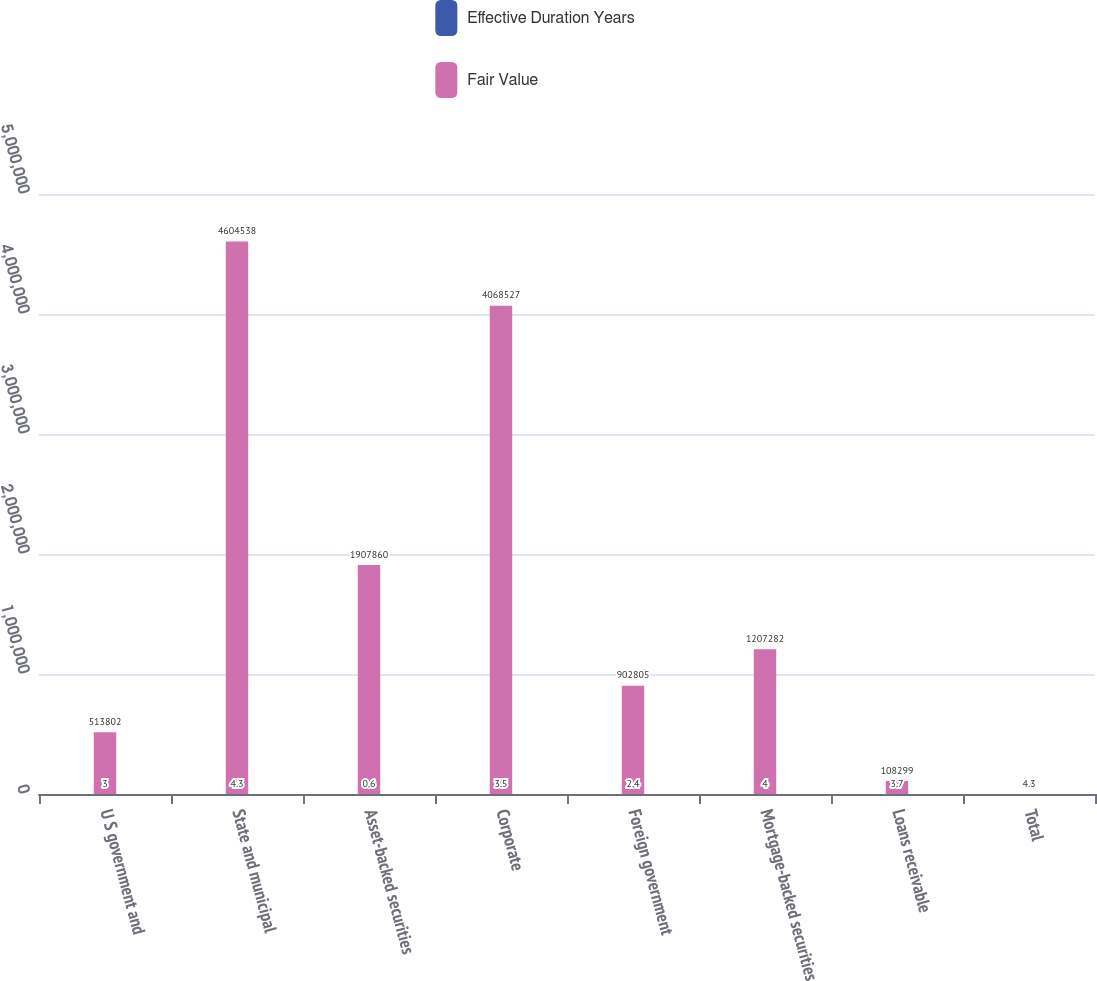<chart> <loc_0><loc_0><loc_500><loc_500><stacked_bar_chart><ecel><fcel>U S government and<fcel>State and municipal<fcel>Asset-backed securities<fcel>Corporate<fcel>Foreign government<fcel>Mortgage-backed securities<fcel>Loans receivable<fcel>Total<nl><fcel>Effective Duration Years<fcel>3<fcel>4.3<fcel>0.6<fcel>3.5<fcel>2.4<fcel>4<fcel>3.7<fcel>3.1<nl><fcel>Fair Value<fcel>513802<fcel>4.60454e+06<fcel>1.90786e+06<fcel>4.06853e+06<fcel>902805<fcel>1.20728e+06<fcel>108299<fcel>4.3<nl></chart> 